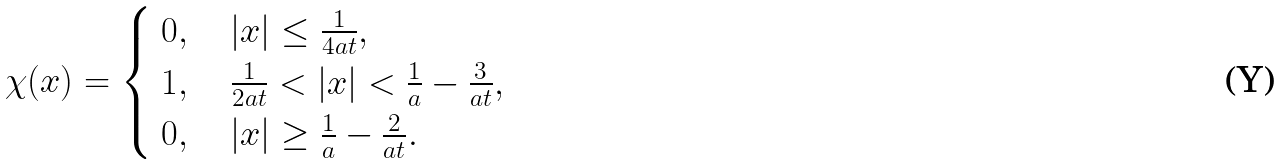Convert formula to latex. <formula><loc_0><loc_0><loc_500><loc_500>\chi ( x ) = \begin{cases} \begin{array} { l } 0 , \quad | x | \leq \frac { 1 } { 4 a t } , \\ 1 , \quad \frac { 1 } { 2 a t } < | x | < \frac { 1 } { a } - \frac { 3 } { a t } , \\ 0 , \quad | x | \geq \frac { 1 } { a } - \frac { 2 } { a t } . \end{array} \end{cases}</formula> 